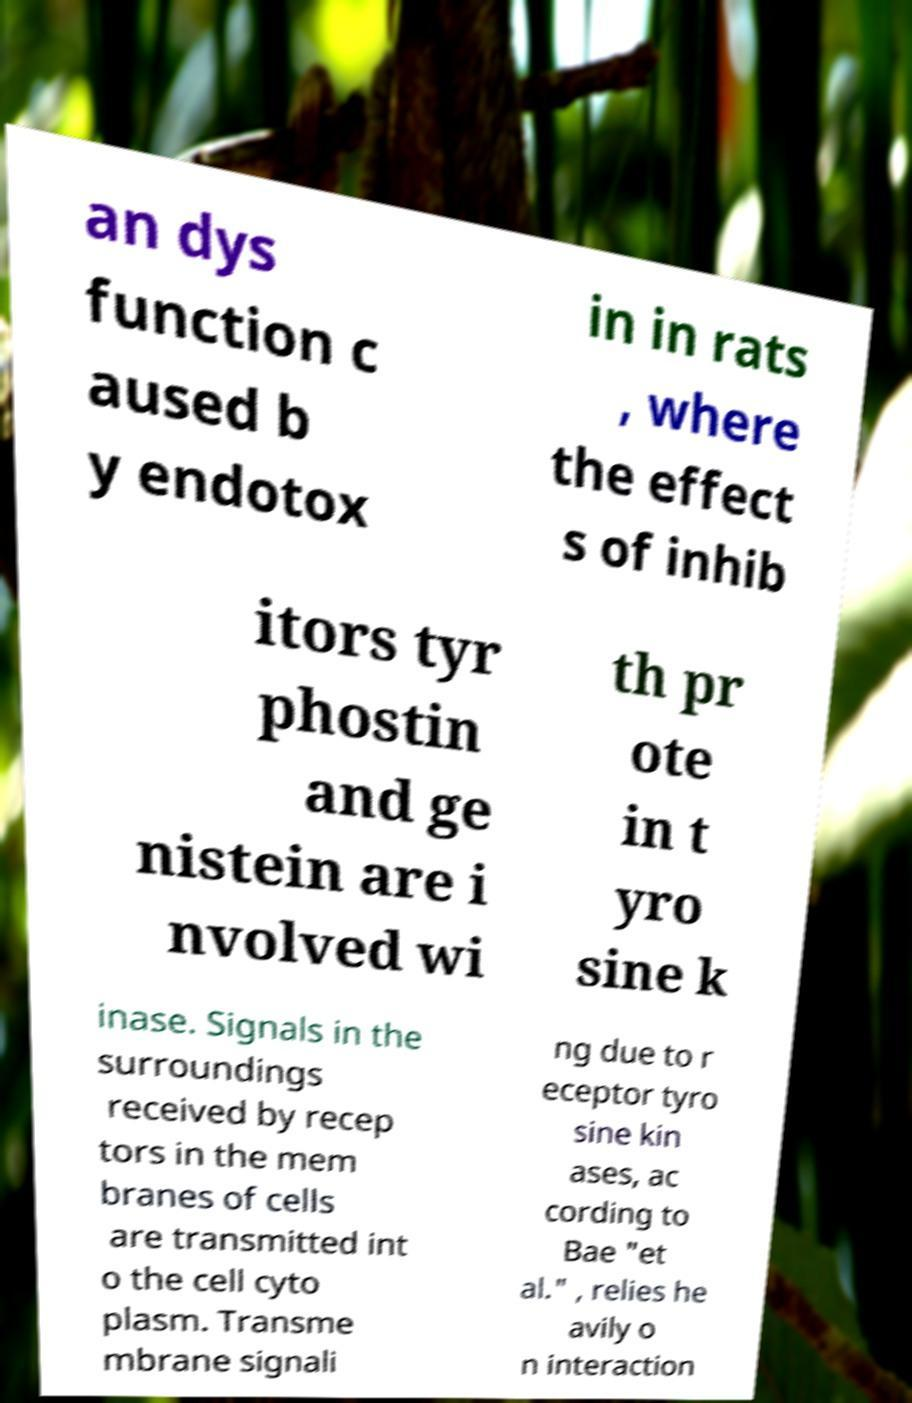Can you read and provide the text displayed in the image?This photo seems to have some interesting text. Can you extract and type it out for me? an dys function c aused b y endotox in in rats , where the effect s of inhib itors tyr phostin and ge nistein are i nvolved wi th pr ote in t yro sine k inase. Signals in the surroundings received by recep tors in the mem branes of cells are transmitted int o the cell cyto plasm. Transme mbrane signali ng due to r eceptor tyro sine kin ases, ac cording to Bae "et al." , relies he avily o n interaction 